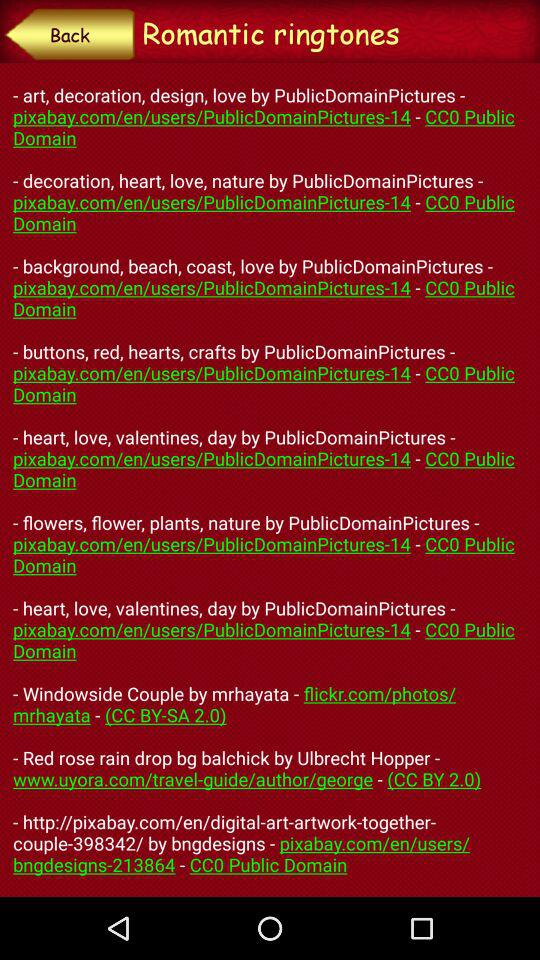What is the name of the ringtone? The ringtone name is "Romantic". 